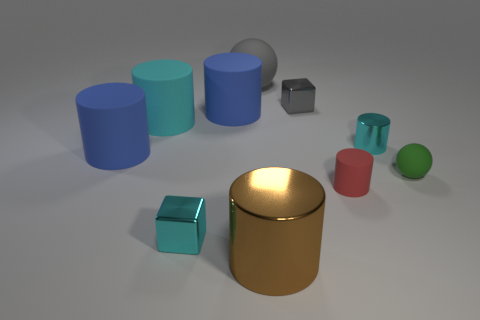Subtract all cyan metallic cylinders. How many cylinders are left? 5 Subtract 2 cylinders. How many cylinders are left? 4 Subtract all red cylinders. How many cylinders are left? 5 Subtract all cyan cylinders. Subtract all blue blocks. How many cylinders are left? 4 Subtract all cubes. How many objects are left? 8 Subtract all spheres. Subtract all tiny green balls. How many objects are left? 7 Add 3 large balls. How many large balls are left? 4 Add 7 small metallic cubes. How many small metallic cubes exist? 9 Subtract 0 purple blocks. How many objects are left? 10 